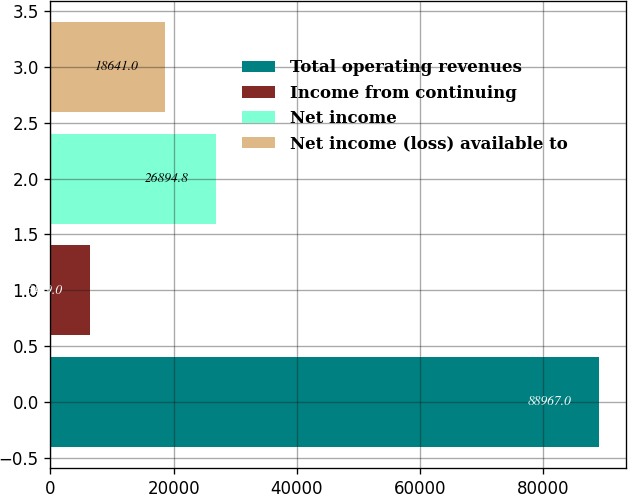Convert chart. <chart><loc_0><loc_0><loc_500><loc_500><bar_chart><fcel>Total operating revenues<fcel>Income from continuing<fcel>Net income<fcel>Net income (loss) available to<nl><fcel>88967<fcel>6429<fcel>26894.8<fcel>18641<nl></chart> 